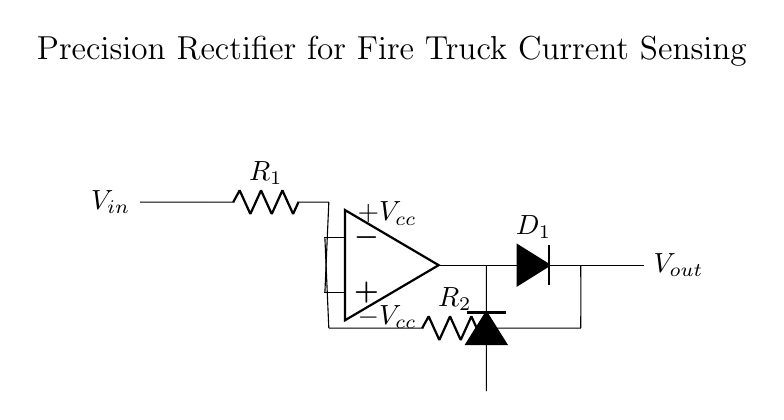What is the input voltage of the circuit? The input voltage is indicated as V in on the left side of the circuit diagram.
Answer: V in What is the output voltage symbol in this circuit? The output voltage is represented by the label V out located at the right side of the circuit diagram.
Answer: V out What are the resistance values used in the circuit? The resistances labeled are R1 and R2, which are identified in the circuit near the operational amplifier.
Answer: R1 and R2 How does the operational amplifier influence this circuit? The operational amplifier amplifies the input signal, enabling greater precision in rectification and current sensing in the fire truck's electrical system.
Answer: Amplification What is the role of the diodes in the precision rectifier? The diodes ensure that only positive portions of the input signal are passed through to the output, thus achieving precision rectification.
Answer: Rectification What happens to the output when the input is negative? When the input is negative, the output voltage will be zero, since the diodes will not conduct, effectively blocking the negative signal.
Answer: Zero How do R1 and R2 affect the output voltage? R1 and R2 set the gain of the operational amplifier, thereby affecting the output voltage magnitude in response to the input current or voltage.
Answer: Gain setting 